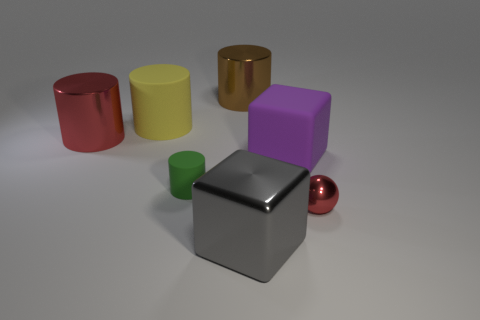Subtract all big brown metallic cylinders. How many cylinders are left? 3 Subtract all green cylinders. How many cylinders are left? 3 Subtract all blue cubes. How many green cylinders are left? 1 Add 2 purple matte blocks. How many objects exist? 9 Subtract 0 brown spheres. How many objects are left? 7 Subtract all cylinders. How many objects are left? 3 Subtract 3 cylinders. How many cylinders are left? 1 Subtract all yellow spheres. Subtract all purple cylinders. How many spheres are left? 1 Subtract all big red cylinders. Subtract all cubes. How many objects are left? 4 Add 7 big brown objects. How many big brown objects are left? 8 